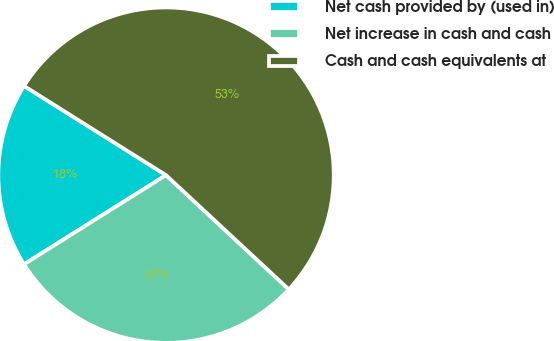<chart> <loc_0><loc_0><loc_500><loc_500><pie_chart><fcel>Net cash provided by (used in)<fcel>Net increase in cash and cash<fcel>Cash and cash equivalents at<nl><fcel>17.85%<fcel>29.15%<fcel>53.0%<nl></chart> 